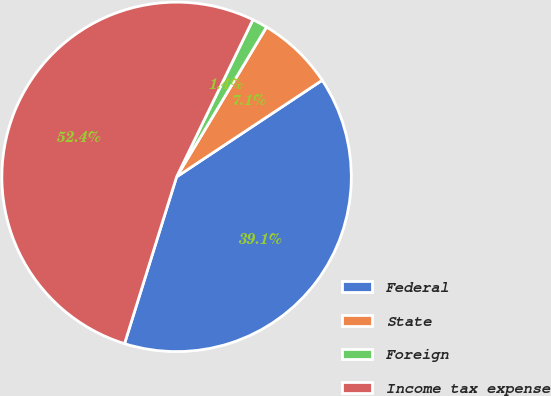Convert chart to OTSL. <chart><loc_0><loc_0><loc_500><loc_500><pie_chart><fcel>Federal<fcel>State<fcel>Foreign<fcel>Income tax expense<nl><fcel>39.14%<fcel>7.07%<fcel>1.41%<fcel>52.38%<nl></chart> 